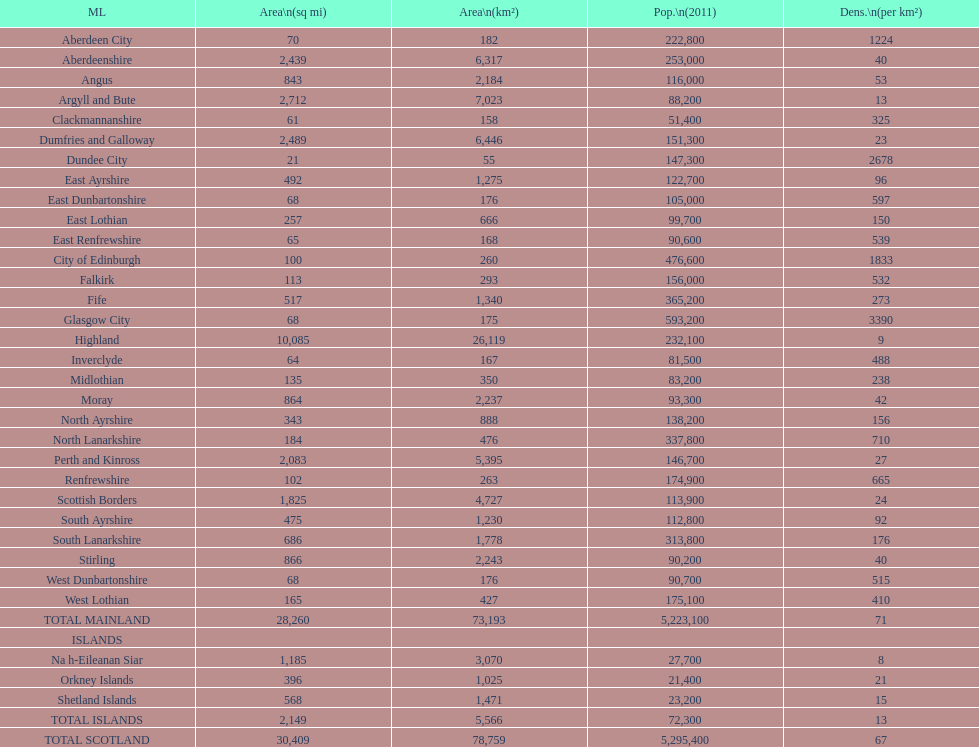What is the number of people living in angus in 2011? 116,000. 